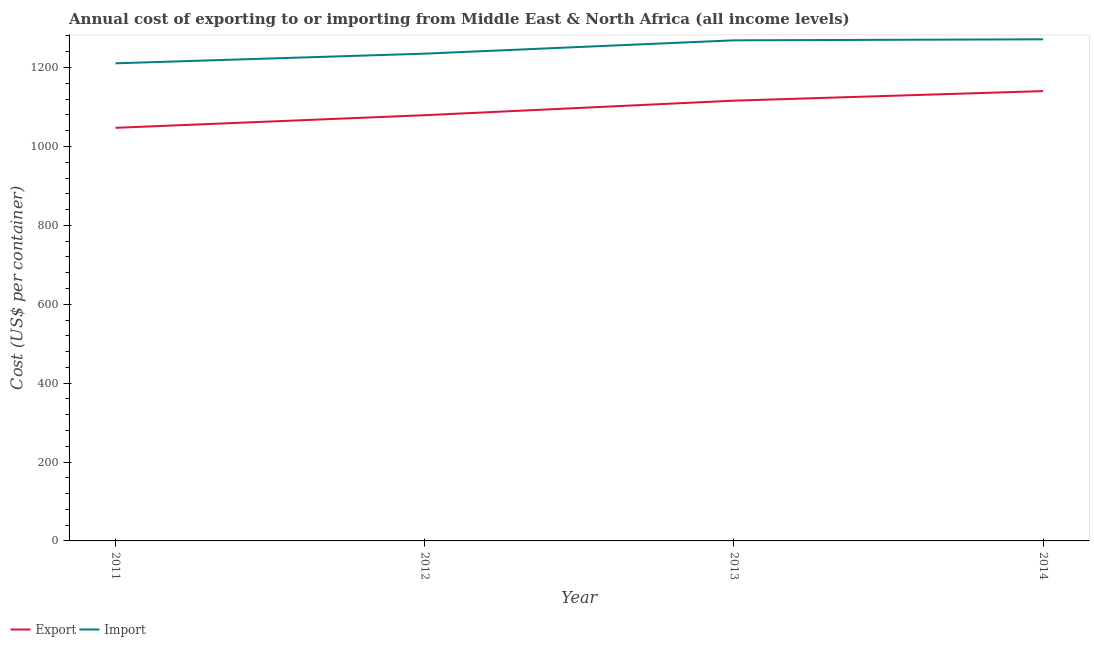Is the number of lines equal to the number of legend labels?
Make the answer very short. Yes. What is the export cost in 2014?
Your answer should be compact. 1140.33. Across all years, what is the maximum import cost?
Provide a succinct answer. 1271.62. Across all years, what is the minimum import cost?
Keep it short and to the point. 1210.75. In which year was the import cost maximum?
Give a very brief answer. 2014. What is the total export cost in the graph?
Give a very brief answer. 4382.77. What is the difference between the export cost in 2011 and that in 2014?
Your response must be concise. -93.13. What is the difference between the import cost in 2012 and the export cost in 2014?
Your response must be concise. 94.9. What is the average export cost per year?
Give a very brief answer. 1095.69. In the year 2011, what is the difference between the export cost and import cost?
Your answer should be very brief. -163.55. What is the ratio of the import cost in 2011 to that in 2012?
Provide a succinct answer. 0.98. Is the import cost in 2011 less than that in 2012?
Your answer should be compact. Yes. Is the difference between the export cost in 2011 and 2014 greater than the difference between the import cost in 2011 and 2014?
Your answer should be very brief. No. What is the difference between the highest and the second highest export cost?
Your response must be concise. 24.29. What is the difference between the highest and the lowest export cost?
Your answer should be very brief. 93.13. In how many years, is the import cost greater than the average import cost taken over all years?
Keep it short and to the point. 2. Is the sum of the export cost in 2012 and 2014 greater than the maximum import cost across all years?
Provide a short and direct response. Yes. Does the export cost monotonically increase over the years?
Offer a terse response. Yes. Is the import cost strictly greater than the export cost over the years?
Make the answer very short. Yes. Does the graph contain grids?
Your answer should be very brief. No. Where does the legend appear in the graph?
Your answer should be very brief. Bottom left. How many legend labels are there?
Keep it short and to the point. 2. How are the legend labels stacked?
Ensure brevity in your answer.  Horizontal. What is the title of the graph?
Give a very brief answer. Annual cost of exporting to or importing from Middle East & North Africa (all income levels). What is the label or title of the Y-axis?
Provide a succinct answer. Cost (US$ per container). What is the Cost (US$ per container) of Export in 2011?
Provide a short and direct response. 1047.2. What is the Cost (US$ per container) in Import in 2011?
Provide a succinct answer. 1210.75. What is the Cost (US$ per container) of Export in 2012?
Your answer should be very brief. 1079.19. What is the Cost (US$ per container) in Import in 2012?
Offer a very short reply. 1235.24. What is the Cost (US$ per container) of Export in 2013?
Your answer should be very brief. 1116.05. What is the Cost (US$ per container) in Import in 2013?
Ensure brevity in your answer.  1269. What is the Cost (US$ per container) of Export in 2014?
Provide a short and direct response. 1140.33. What is the Cost (US$ per container) of Import in 2014?
Offer a terse response. 1271.62. Across all years, what is the maximum Cost (US$ per container) of Export?
Offer a very short reply. 1140.33. Across all years, what is the maximum Cost (US$ per container) in Import?
Give a very brief answer. 1271.62. Across all years, what is the minimum Cost (US$ per container) of Export?
Provide a succinct answer. 1047.2. Across all years, what is the minimum Cost (US$ per container) of Import?
Provide a succinct answer. 1210.75. What is the total Cost (US$ per container) in Export in the graph?
Ensure brevity in your answer.  4382.77. What is the total Cost (US$ per container) in Import in the graph?
Keep it short and to the point. 4986.61. What is the difference between the Cost (US$ per container) of Export in 2011 and that in 2012?
Provide a short and direct response. -31.99. What is the difference between the Cost (US$ per container) in Import in 2011 and that in 2012?
Your answer should be very brief. -24.49. What is the difference between the Cost (US$ per container) in Export in 2011 and that in 2013?
Offer a very short reply. -68.85. What is the difference between the Cost (US$ per container) of Import in 2011 and that in 2013?
Offer a terse response. -58.25. What is the difference between the Cost (US$ per container) of Export in 2011 and that in 2014?
Keep it short and to the point. -93.13. What is the difference between the Cost (US$ per container) in Import in 2011 and that in 2014?
Your answer should be very brief. -60.87. What is the difference between the Cost (US$ per container) of Export in 2012 and that in 2013?
Offer a terse response. -36.86. What is the difference between the Cost (US$ per container) of Import in 2012 and that in 2013?
Provide a succinct answer. -33.76. What is the difference between the Cost (US$ per container) of Export in 2012 and that in 2014?
Provide a succinct answer. -61.14. What is the difference between the Cost (US$ per container) in Import in 2012 and that in 2014?
Provide a succinct answer. -36.38. What is the difference between the Cost (US$ per container) in Export in 2013 and that in 2014?
Provide a succinct answer. -24.29. What is the difference between the Cost (US$ per container) in Import in 2013 and that in 2014?
Your answer should be very brief. -2.62. What is the difference between the Cost (US$ per container) of Export in 2011 and the Cost (US$ per container) of Import in 2012?
Keep it short and to the point. -188.04. What is the difference between the Cost (US$ per container) of Export in 2011 and the Cost (US$ per container) of Import in 2013?
Offer a very short reply. -221.8. What is the difference between the Cost (US$ per container) of Export in 2011 and the Cost (US$ per container) of Import in 2014?
Ensure brevity in your answer.  -224.42. What is the difference between the Cost (US$ per container) in Export in 2012 and the Cost (US$ per container) in Import in 2013?
Ensure brevity in your answer.  -189.81. What is the difference between the Cost (US$ per container) of Export in 2012 and the Cost (US$ per container) of Import in 2014?
Make the answer very short. -192.43. What is the difference between the Cost (US$ per container) in Export in 2013 and the Cost (US$ per container) in Import in 2014?
Offer a terse response. -155.57. What is the average Cost (US$ per container) of Export per year?
Offer a very short reply. 1095.69. What is the average Cost (US$ per container) of Import per year?
Provide a short and direct response. 1246.65. In the year 2011, what is the difference between the Cost (US$ per container) in Export and Cost (US$ per container) in Import?
Give a very brief answer. -163.55. In the year 2012, what is the difference between the Cost (US$ per container) of Export and Cost (US$ per container) of Import?
Offer a very short reply. -156.05. In the year 2013, what is the difference between the Cost (US$ per container) in Export and Cost (US$ per container) in Import?
Provide a short and direct response. -152.95. In the year 2014, what is the difference between the Cost (US$ per container) in Export and Cost (US$ per container) in Import?
Your answer should be compact. -131.29. What is the ratio of the Cost (US$ per container) in Export in 2011 to that in 2012?
Offer a very short reply. 0.97. What is the ratio of the Cost (US$ per container) of Import in 2011 to that in 2012?
Give a very brief answer. 0.98. What is the ratio of the Cost (US$ per container) of Export in 2011 to that in 2013?
Your answer should be very brief. 0.94. What is the ratio of the Cost (US$ per container) in Import in 2011 to that in 2013?
Make the answer very short. 0.95. What is the ratio of the Cost (US$ per container) in Export in 2011 to that in 2014?
Offer a very short reply. 0.92. What is the ratio of the Cost (US$ per container) in Import in 2011 to that in 2014?
Make the answer very short. 0.95. What is the ratio of the Cost (US$ per container) in Import in 2012 to that in 2013?
Your answer should be compact. 0.97. What is the ratio of the Cost (US$ per container) of Export in 2012 to that in 2014?
Provide a succinct answer. 0.95. What is the ratio of the Cost (US$ per container) in Import in 2012 to that in 2014?
Keep it short and to the point. 0.97. What is the ratio of the Cost (US$ per container) in Export in 2013 to that in 2014?
Your response must be concise. 0.98. What is the difference between the highest and the second highest Cost (US$ per container) of Export?
Keep it short and to the point. 24.29. What is the difference between the highest and the second highest Cost (US$ per container) of Import?
Offer a terse response. 2.62. What is the difference between the highest and the lowest Cost (US$ per container) of Export?
Ensure brevity in your answer.  93.13. What is the difference between the highest and the lowest Cost (US$ per container) of Import?
Keep it short and to the point. 60.87. 